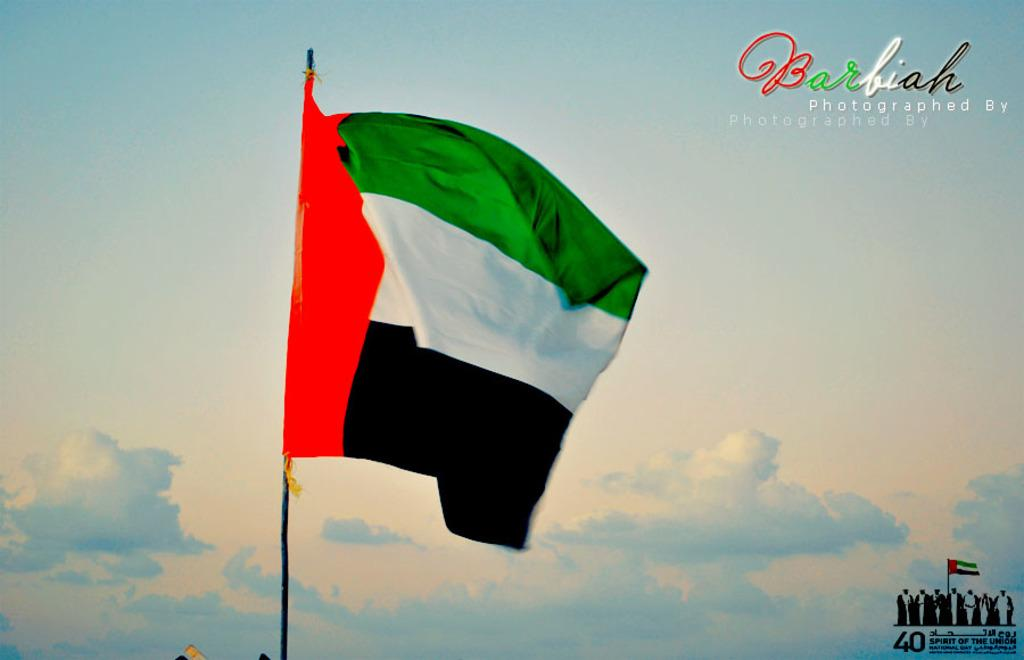What can be seen in the image that represents a symbol or country? There is a flag in the image. Where is the text located in the top right corner of the image? There is text in the top right corner of the image. Where is the text located in the bottom right corner of the image? There is text in the bottom right corner of the image. What type of vacation is being advertised in the image? There is no information about a vacation in the image; it only contains a flag and text in the corners. Can you see any trousers being worn by someone in the image? There are no people or clothing items visible in the image. 